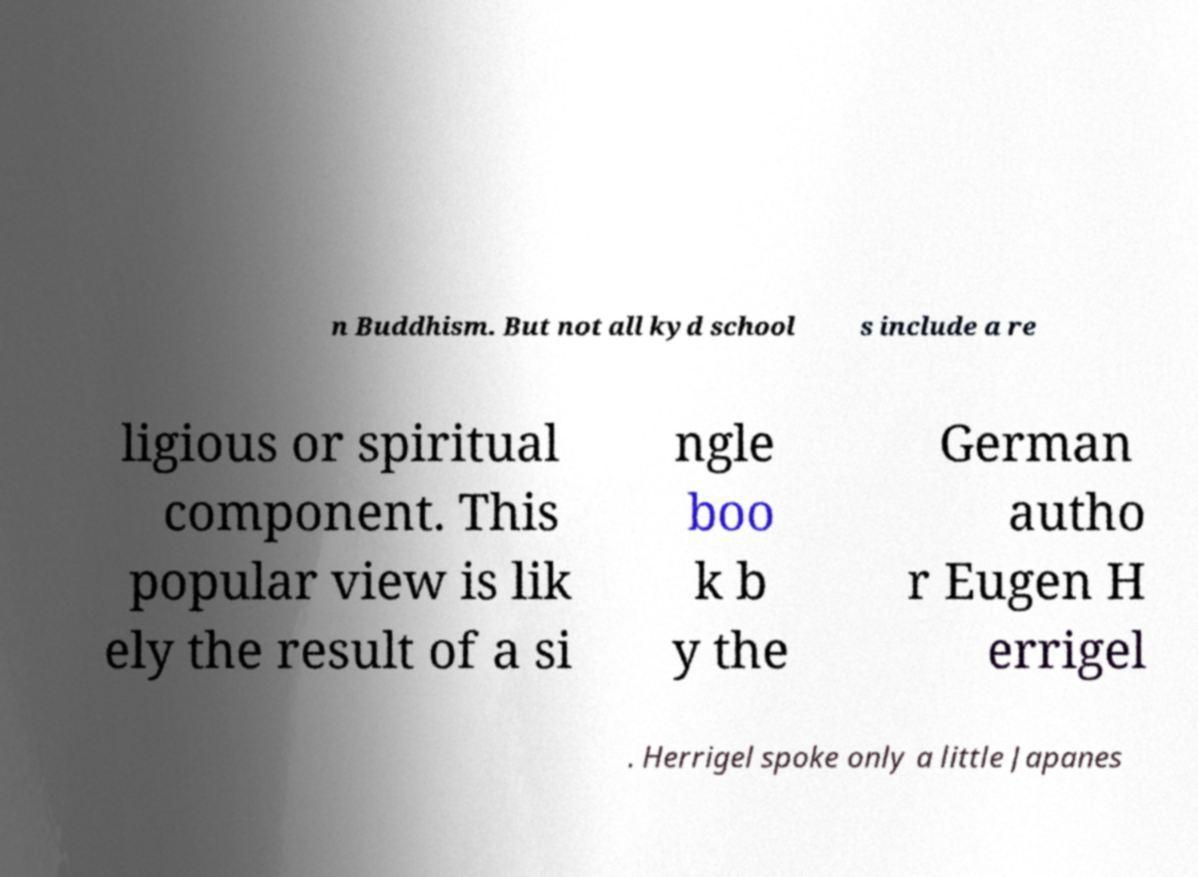For documentation purposes, I need the text within this image transcribed. Could you provide that? n Buddhism. But not all kyd school s include a re ligious or spiritual component. This popular view is lik ely the result of a si ngle boo k b y the German autho r Eugen H errigel . Herrigel spoke only a little Japanes 